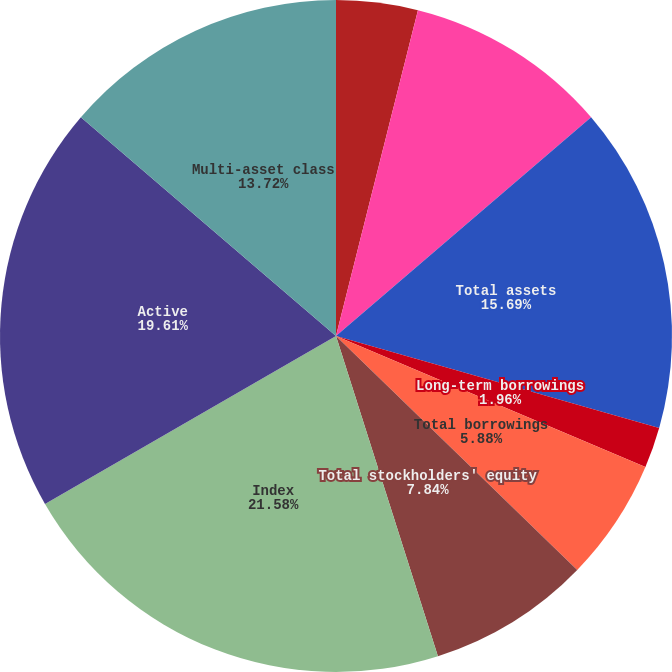Convert chart. <chart><loc_0><loc_0><loc_500><loc_500><pie_chart><fcel>Cash and cash equivalents<fcel>Goodwill and intangible assets<fcel>Total assets<fcel>Convertible debentures<fcel>Long-term borrowings<fcel>Total borrowings<fcel>Total stockholders' equity<fcel>Index<fcel>Active<fcel>Multi-asset class<nl><fcel>3.92%<fcel>9.8%<fcel>15.69%<fcel>0.0%<fcel>1.96%<fcel>5.88%<fcel>7.84%<fcel>21.57%<fcel>19.61%<fcel>13.72%<nl></chart> 